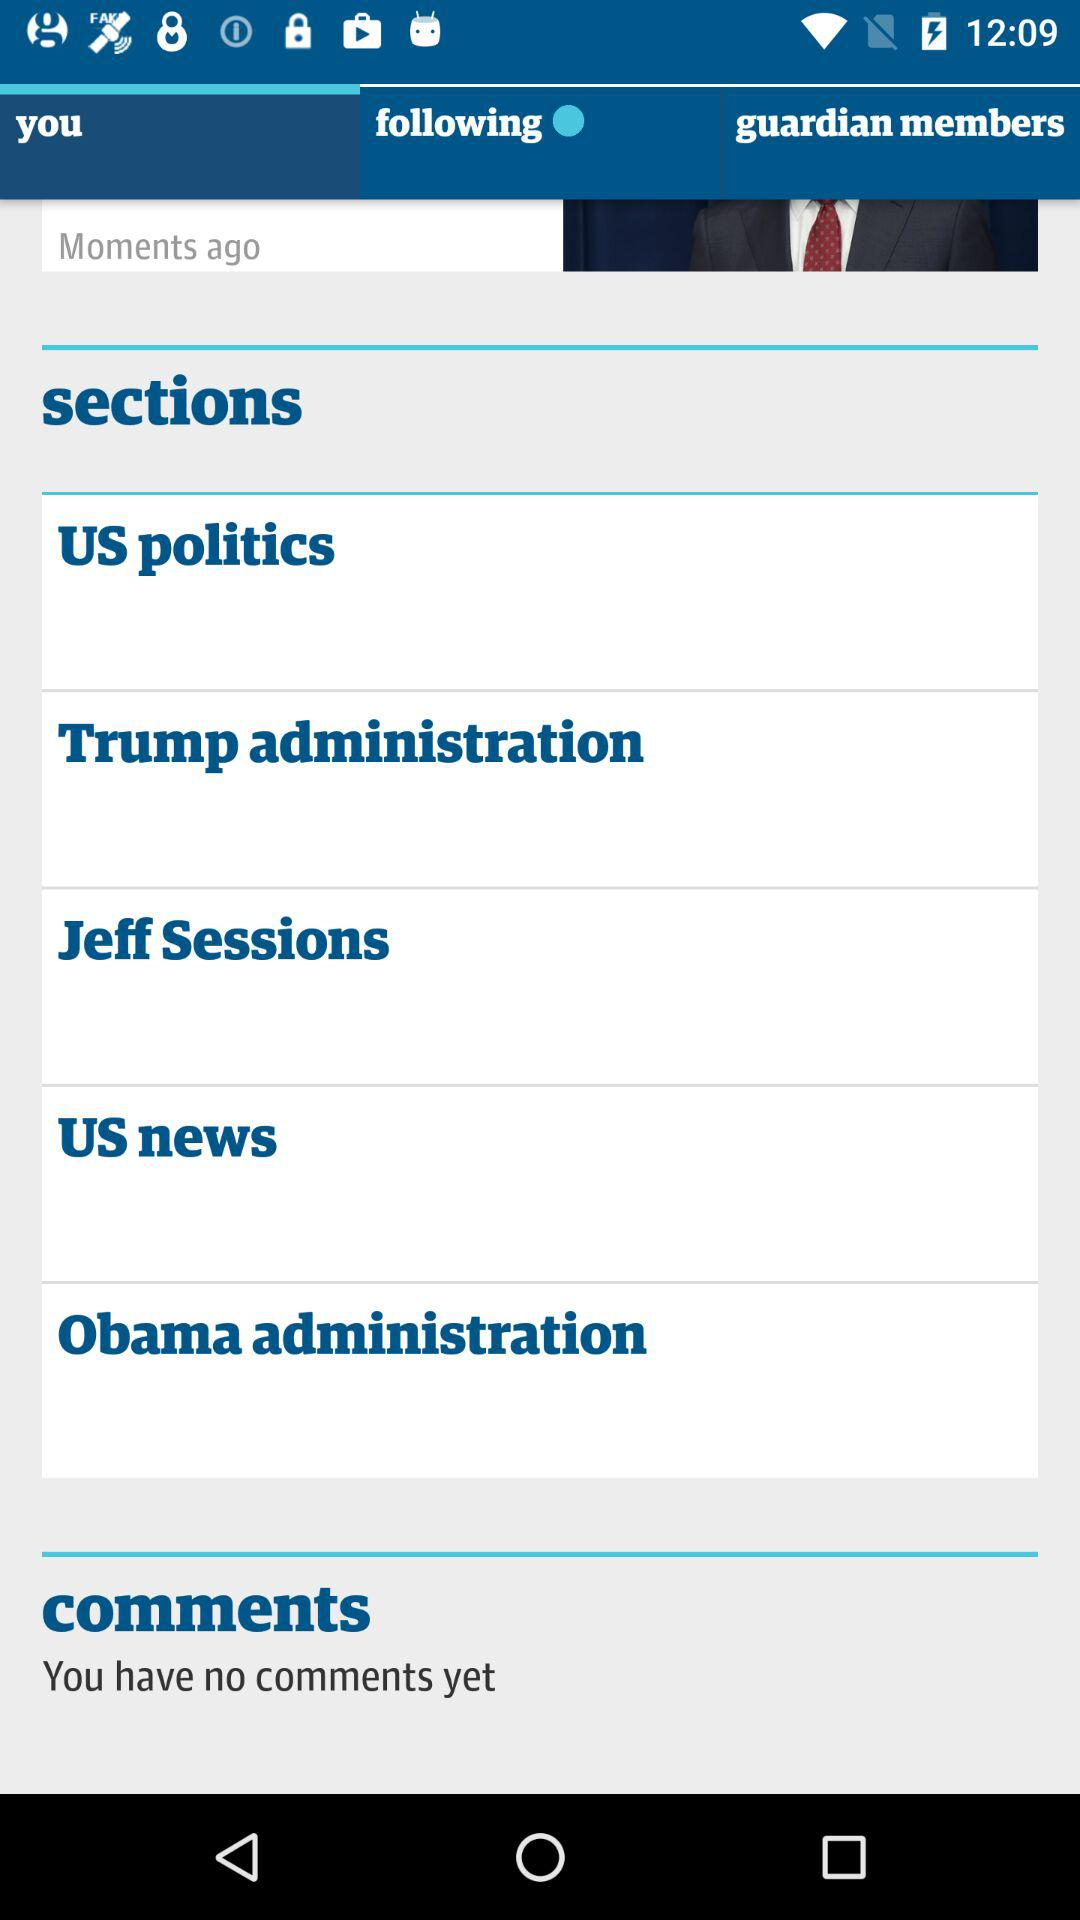How many comments are on the screen?
Answer the question using a single word or phrase. 0 